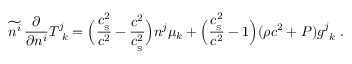Convert formula to latex. <formula><loc_0><loc_0><loc_500><loc_500>\widetilde { n ^ { i } } \, { \frac { \partial } { \partial n ^ { i } } } T _ { \ k } ^ { j } = \left ( { \frac { c _ { _ { S } } ^ { 2 } } { c ^ { 2 } } } - { \frac { c ^ { 2 } } { c _ { _ { S } } ^ { 2 } } } \right ) n ^ { j } \mu _ { k } + \left ( { \frac { c _ { _ { S } } ^ { 2 } } { c ^ { 2 } } } - 1 \right ) ( \rho c ^ { 2 } + P ) g _ { \ k } ^ { j } \ .</formula> 